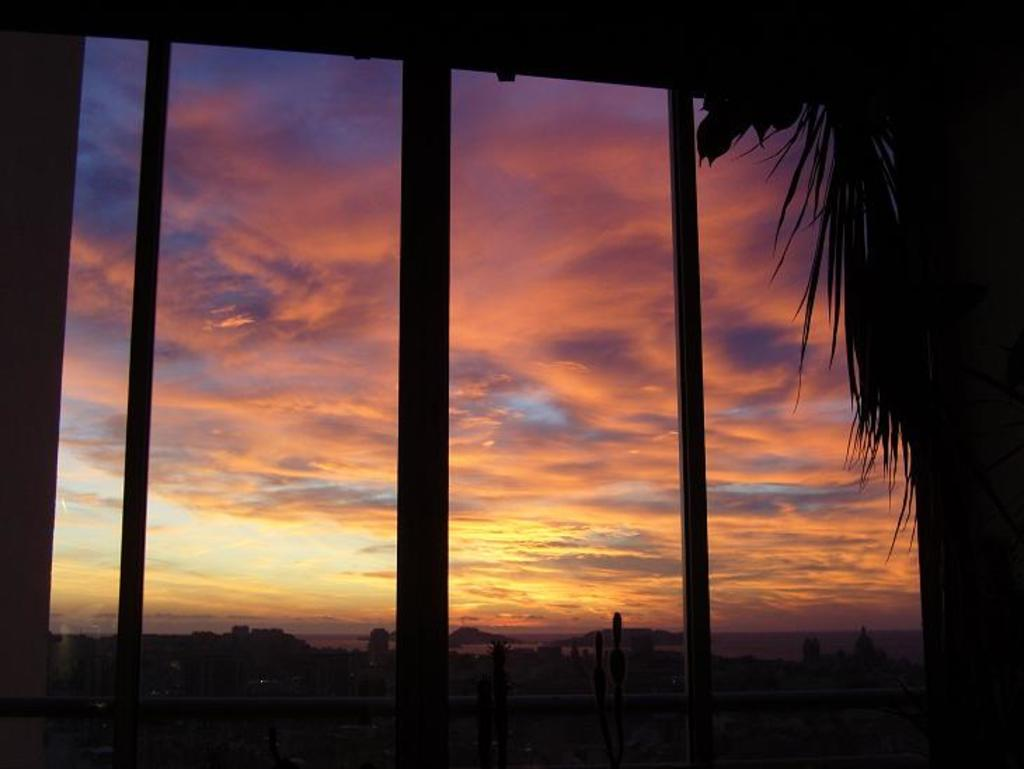What is located in the foreground of the image? There is a window in the foreground of the image. What can be seen on the right side of the image? There are leaves on the right side of the image. What is visible in the background of the image? The sky is visible in the background of the image. What else can be seen in the background of the image? There are objects in the background of the image. Can you tell me how many jellyfish are swimming in the window in the image? There are no jellyfish present in the image, as it features a window with leaves and objects in the background. 